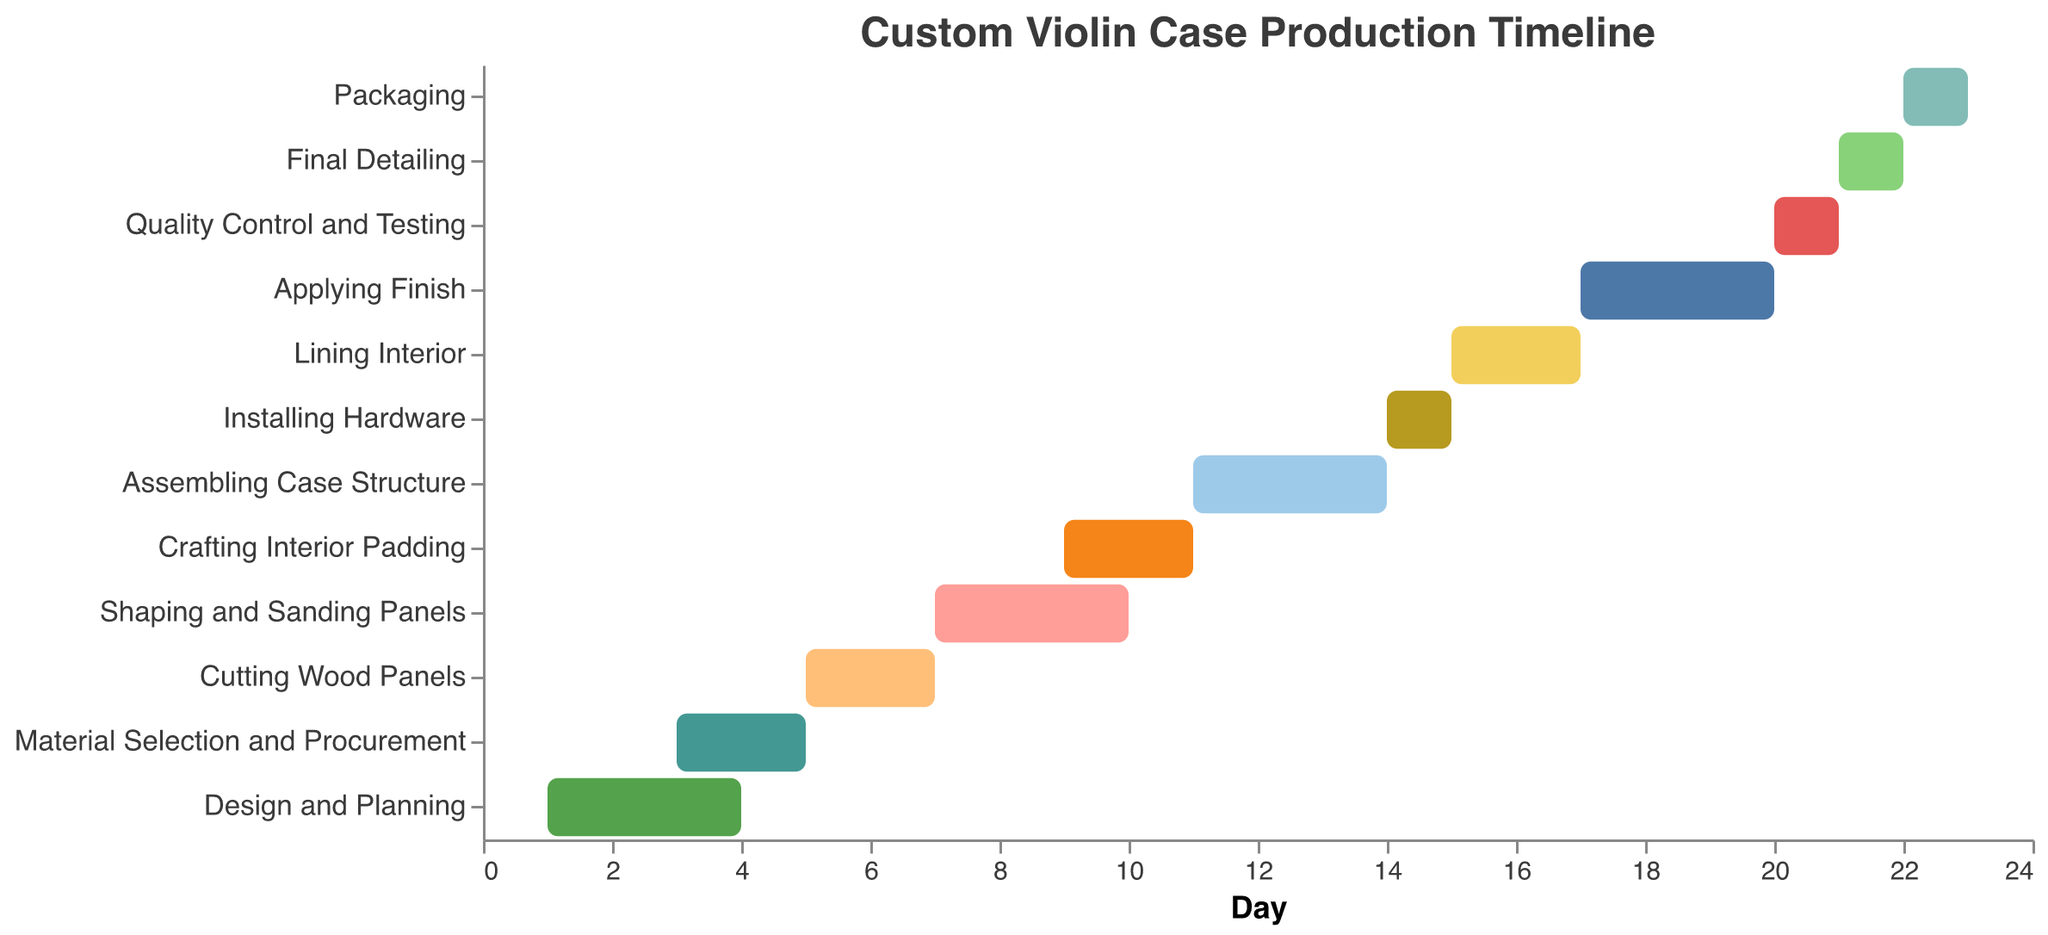What is the total duration of the "Design and Planning" task? The bar labeled "Design and Planning" starts at day 1 and lasts for 3 days.
Answer: 3 days When does the "Applying Finish" task end? The "Applying Finish" task starts at day 17 and has a duration of 3 days. The end day is calculated as 17 + 3.
Answer: Day 20 Which task occurs immediately after "Material Selection and Procurement"? According to the timeline, "Cutting Wood Panels" starts immediately after "Material Selection and Procurement" ends.
Answer: Cutting Wood Panels How many tasks take exactly 3 days to complete? By inspecting the plot, the tasks "Design and Planning", "Shaping and Sanding Panels", "Assembling Case Structure", and "Applying Finish" each have a duration of 3 days.
Answer: 4 tasks Which task has the shortest duration? "Installing Hardware", "Quality Control and Testing", "Final Detailing", and "Packaging" each have the shortest duration of 1 day.
Answer: Installing Hardware, Quality Control and Testing, Final Detailing, Packaging How many days are required from the start of "Design and Planning" to the end of "Applying Finish"? "Design and Planning" starts on day 1 and "Applying Finish" ends on day 20. The total duration is 20 - 1 + 3 = 22 days.
Answer: 19 days Which tasks overlap with the "Shaping and Sanding Panels" task? "Shaping and Sanding Panels" runs from day 7 to day 10. The tasks that overlap with this period are "Cutting Wood Panels" (day 5 to day 7, overlaps on day 7) and "Crafting Interior Padding" (day 9 to day 11, overlaps on days 9 & 10).
Answer: Cutting Wood Panels and Crafting Interior Padding In which task do you have the highest number of Gantt bars displayed? When observing the Gantt chart, each task displays exactly one Gantt bar. Hence, there is no task with multiple Gantt bars.
Answer: Every task has an equal number of Gantt bars Which task starts first and which task ends last? The Gantt chart indicates "Design and Planning" starts first at day 1, and "Packaging" ends last on day 23.
Answer: "Design and Planning" starts first; "Packaging" ends last Which tasks have durations that overlap with more than one other task? "Shaping and Sanding Panels" overlaps with both "Cutting Wood Panels" and "Crafting Interior Padding"; "Assembling Case Structure" overlaps with "Crafting Interior Padding" and "Installing Hardware"; "Applying Finish" overlaps with "Lining Interior" and "Quality Control and Testing."
Answer: Shaping and Sanding Panels, Assembling Case Structure, Applying Finish 